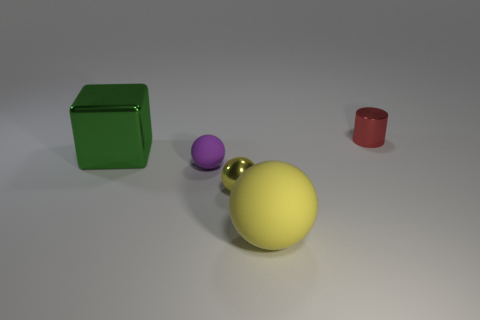The small object that is on the right side of the tiny metallic thing in front of the red metallic thing is what shape?
Your answer should be very brief. Cylinder. What size is the yellow sphere in front of the tiny metallic object that is in front of the large green cube?
Provide a short and direct response. Large. There is a matte object that is left of the yellow metallic object; what is its color?
Your answer should be very brief. Purple. What size is the ball that is the same material as the cylinder?
Provide a succinct answer. Small. How many green shiny objects are the same shape as the purple rubber thing?
Offer a very short reply. 0. What material is the purple sphere that is the same size as the yellow metal ball?
Offer a terse response. Rubber. Are there any large green objects made of the same material as the red object?
Ensure brevity in your answer.  Yes. The thing that is both on the right side of the shiny ball and behind the big rubber thing is what color?
Make the answer very short. Red. What number of other objects are there of the same color as the big sphere?
Provide a succinct answer. 1. There is a purple object behind the matte object right of the small metal object in front of the cylinder; what is it made of?
Your answer should be compact. Rubber. 